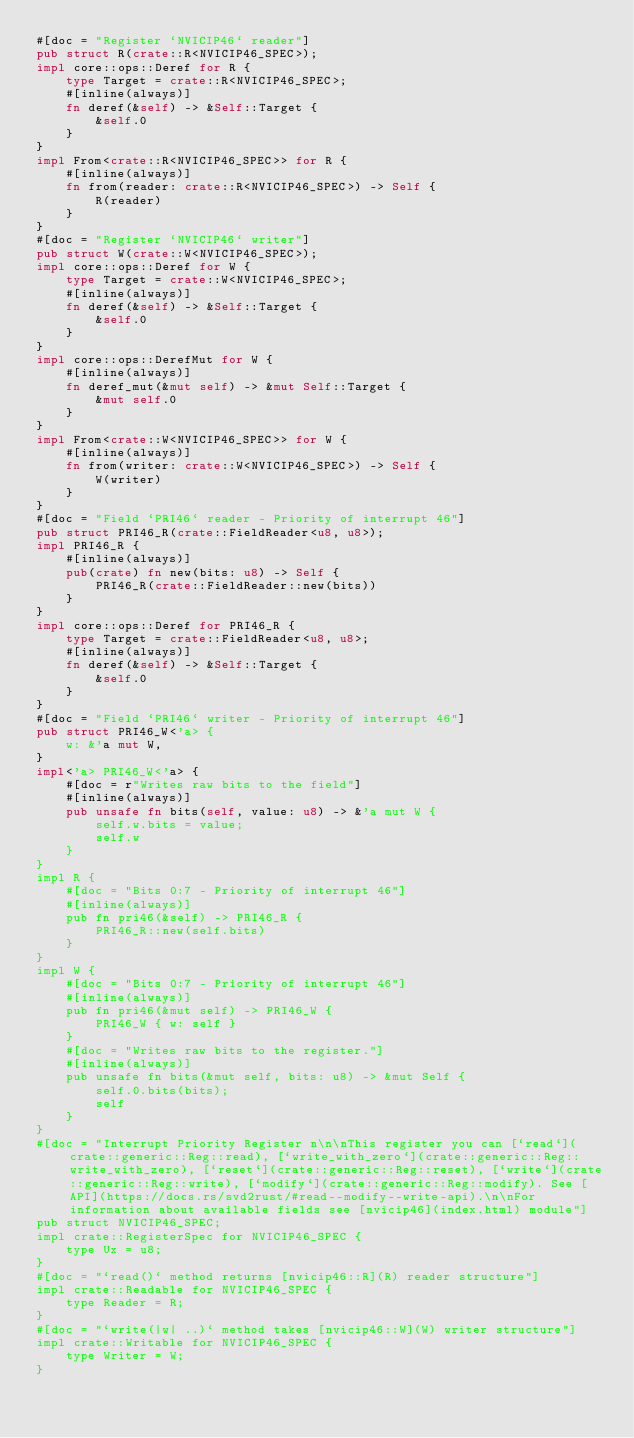Convert code to text. <code><loc_0><loc_0><loc_500><loc_500><_Rust_>#[doc = "Register `NVICIP46` reader"]
pub struct R(crate::R<NVICIP46_SPEC>);
impl core::ops::Deref for R {
    type Target = crate::R<NVICIP46_SPEC>;
    #[inline(always)]
    fn deref(&self) -> &Self::Target {
        &self.0
    }
}
impl From<crate::R<NVICIP46_SPEC>> for R {
    #[inline(always)]
    fn from(reader: crate::R<NVICIP46_SPEC>) -> Self {
        R(reader)
    }
}
#[doc = "Register `NVICIP46` writer"]
pub struct W(crate::W<NVICIP46_SPEC>);
impl core::ops::Deref for W {
    type Target = crate::W<NVICIP46_SPEC>;
    #[inline(always)]
    fn deref(&self) -> &Self::Target {
        &self.0
    }
}
impl core::ops::DerefMut for W {
    #[inline(always)]
    fn deref_mut(&mut self) -> &mut Self::Target {
        &mut self.0
    }
}
impl From<crate::W<NVICIP46_SPEC>> for W {
    #[inline(always)]
    fn from(writer: crate::W<NVICIP46_SPEC>) -> Self {
        W(writer)
    }
}
#[doc = "Field `PRI46` reader - Priority of interrupt 46"]
pub struct PRI46_R(crate::FieldReader<u8, u8>);
impl PRI46_R {
    #[inline(always)]
    pub(crate) fn new(bits: u8) -> Self {
        PRI46_R(crate::FieldReader::new(bits))
    }
}
impl core::ops::Deref for PRI46_R {
    type Target = crate::FieldReader<u8, u8>;
    #[inline(always)]
    fn deref(&self) -> &Self::Target {
        &self.0
    }
}
#[doc = "Field `PRI46` writer - Priority of interrupt 46"]
pub struct PRI46_W<'a> {
    w: &'a mut W,
}
impl<'a> PRI46_W<'a> {
    #[doc = r"Writes raw bits to the field"]
    #[inline(always)]
    pub unsafe fn bits(self, value: u8) -> &'a mut W {
        self.w.bits = value;
        self.w
    }
}
impl R {
    #[doc = "Bits 0:7 - Priority of interrupt 46"]
    #[inline(always)]
    pub fn pri46(&self) -> PRI46_R {
        PRI46_R::new(self.bits)
    }
}
impl W {
    #[doc = "Bits 0:7 - Priority of interrupt 46"]
    #[inline(always)]
    pub fn pri46(&mut self) -> PRI46_W {
        PRI46_W { w: self }
    }
    #[doc = "Writes raw bits to the register."]
    #[inline(always)]
    pub unsafe fn bits(&mut self, bits: u8) -> &mut Self {
        self.0.bits(bits);
        self
    }
}
#[doc = "Interrupt Priority Register n\n\nThis register you can [`read`](crate::generic::Reg::read), [`write_with_zero`](crate::generic::Reg::write_with_zero), [`reset`](crate::generic::Reg::reset), [`write`](crate::generic::Reg::write), [`modify`](crate::generic::Reg::modify). See [API](https://docs.rs/svd2rust/#read--modify--write-api).\n\nFor information about available fields see [nvicip46](index.html) module"]
pub struct NVICIP46_SPEC;
impl crate::RegisterSpec for NVICIP46_SPEC {
    type Ux = u8;
}
#[doc = "`read()` method returns [nvicip46::R](R) reader structure"]
impl crate::Readable for NVICIP46_SPEC {
    type Reader = R;
}
#[doc = "`write(|w| ..)` method takes [nvicip46::W](W) writer structure"]
impl crate::Writable for NVICIP46_SPEC {
    type Writer = W;
}</code> 